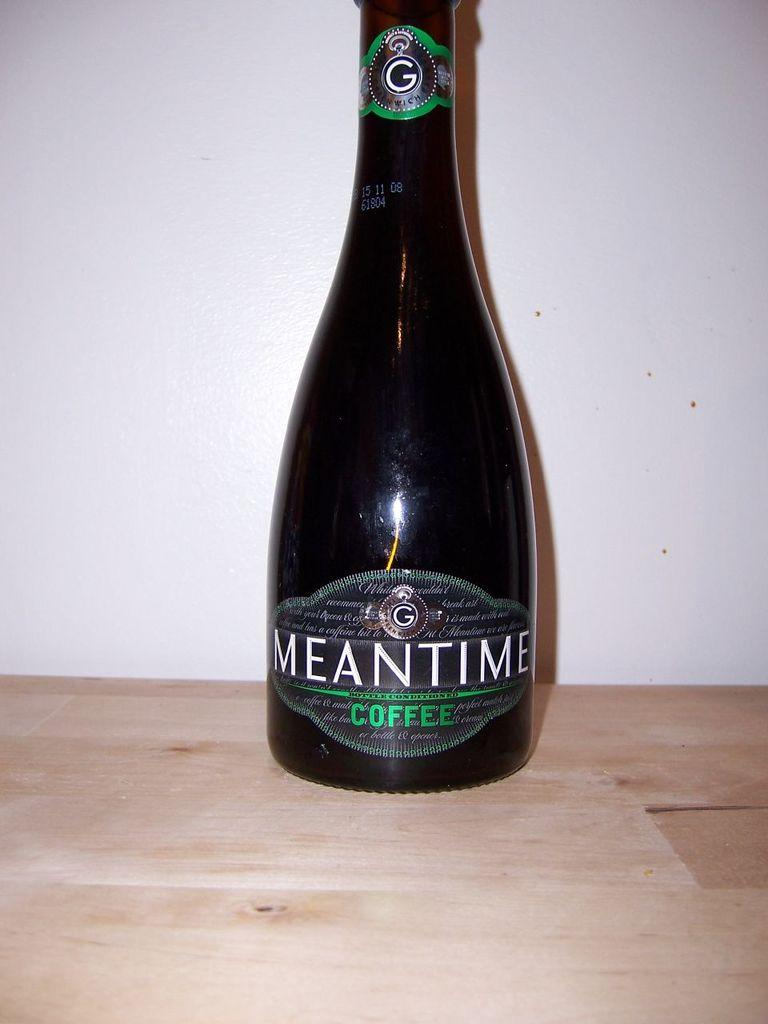<image>
Summarize the visual content of the image. Bottle of coffee with the label saying Meantime Coffee. 